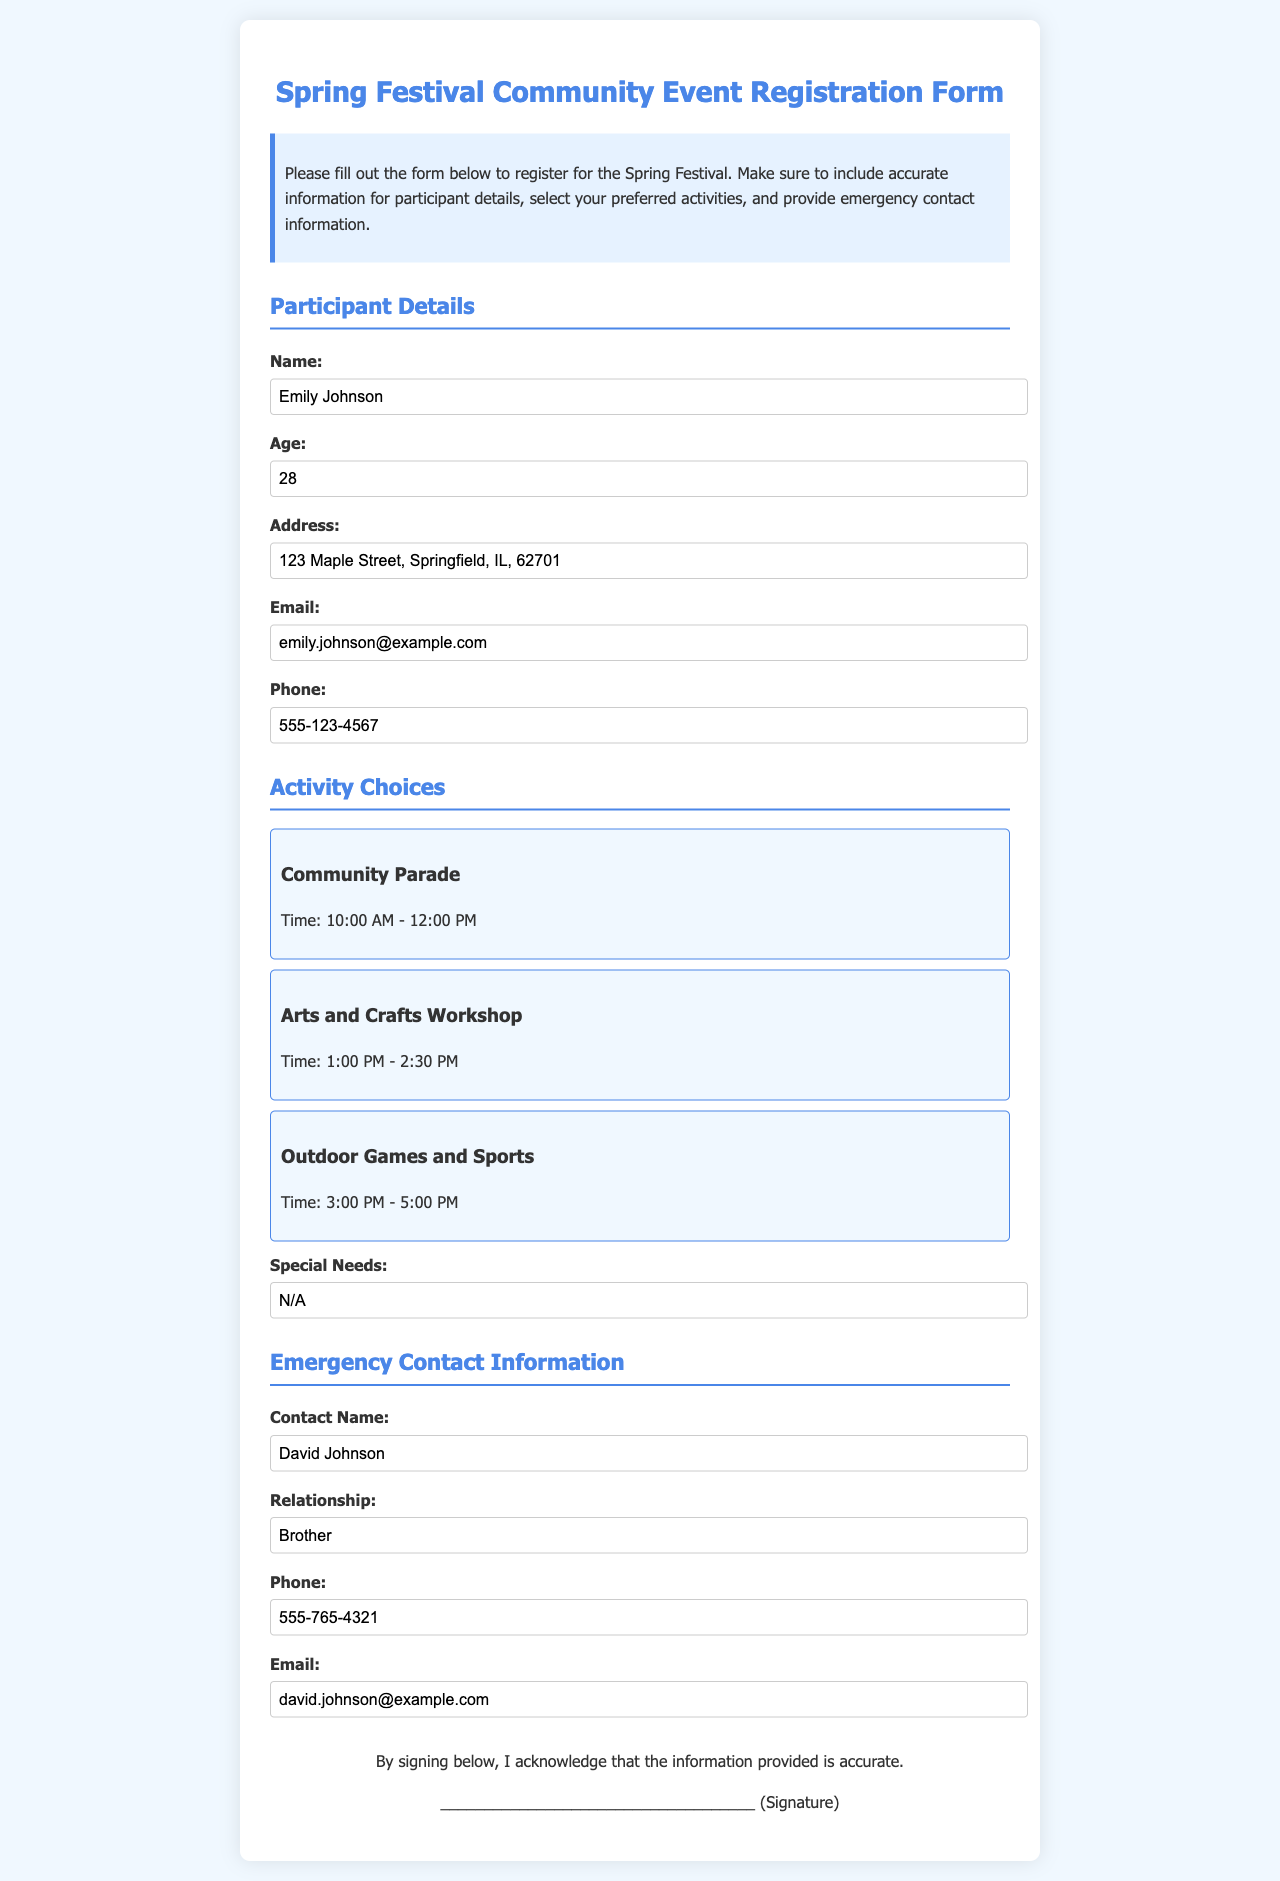what is the name of the participant? The name of the participant is provided in the participant details section.
Answer: Emily Johnson what is the age of the participant? The age of the participant is listed in the participant details section of the form.
Answer: 28 what is the address of the participant? The address of the participant is found in the participant details section.
Answer: 123 Maple Street, Springfield, IL, 62701 which activity starts at 10:00 AM? The starting time of activities is listed in the activity choices section.
Answer: Community Parade who is the emergency contact? The emergency contact's name is provided in the emergency contact information section.
Answer: David Johnson what is the relationship of the emergency contact to the participant? The relationship is specified in the emergency contact information section.
Answer: Brother what is the emergency contact's phone number? The phone number of the emergency contact can be found in the emergency contact information section.
Answer: 555-765-4321 does the participant have any special needs? Information regarding special needs is listed in the activity choices section.
Answer: N/A what is the email of the emergency contact? The emergency contact's email is provided in the emergency contact information section of the form.
Answer: david.johnson@example.com 